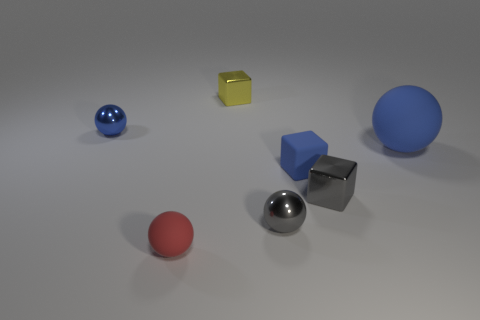What time of day or lighting scenario does the shadowing in the image suggest? The shadowing in the image suggests an environment with a single light source located above and to the left, potentially resembling indoor lighting. The shadows are diffused, indicating that the light source is not extremely close to the objects. 